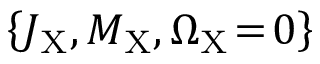Convert formula to latex. <formula><loc_0><loc_0><loc_500><loc_500>\left \{ J _ { X } , M _ { X } , \Omega _ { X } \, = \, 0 \right \}</formula> 